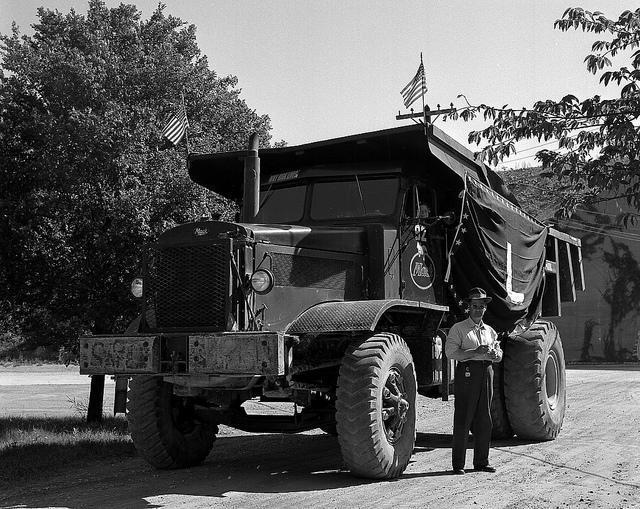How many horses are there?
Give a very brief answer. 0. 